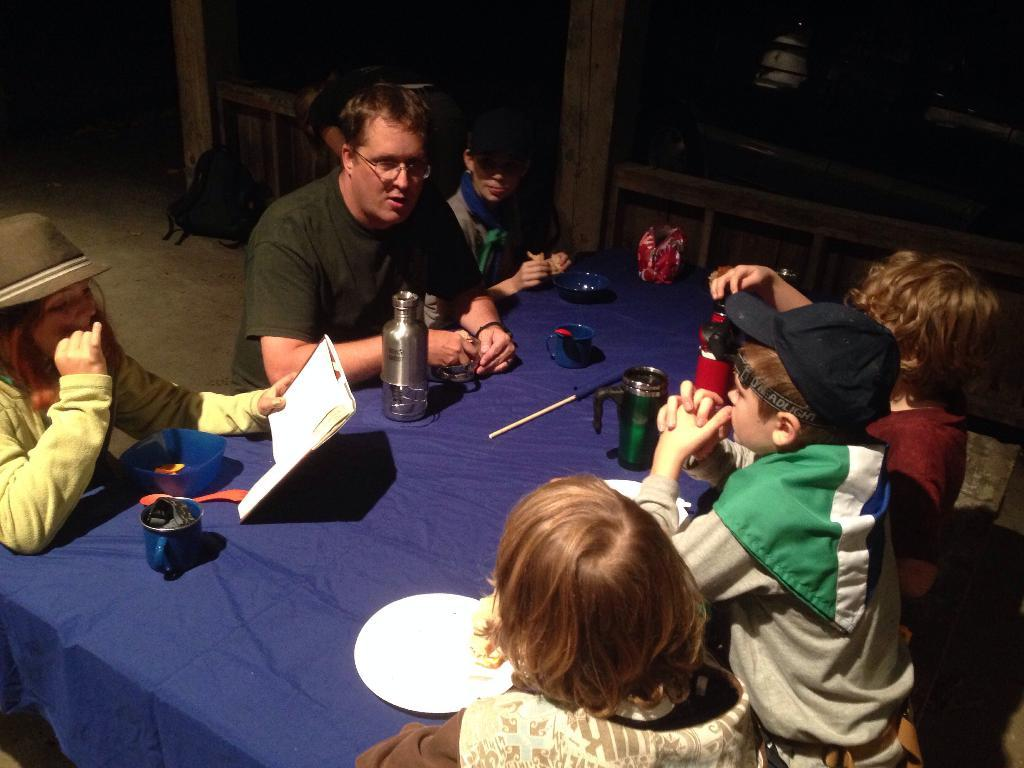Who is present in the image with the group of children? There is a man in the image with the group of children. What is the man doing with the children? The man is sitting with the group of children. What objects can be seen on the table in the image? There are flasks, boxes, cups, and plates on the table in the image. What color is the cloth on the table? The cloth on the table is blue. What type of dirt can be seen on the man's shoes in the image? There is no dirt visible on the man's shoes in the image. What kind of stitch is used to repair the children's clothing in the image? There is no mention of clothing or stitching in the image. 